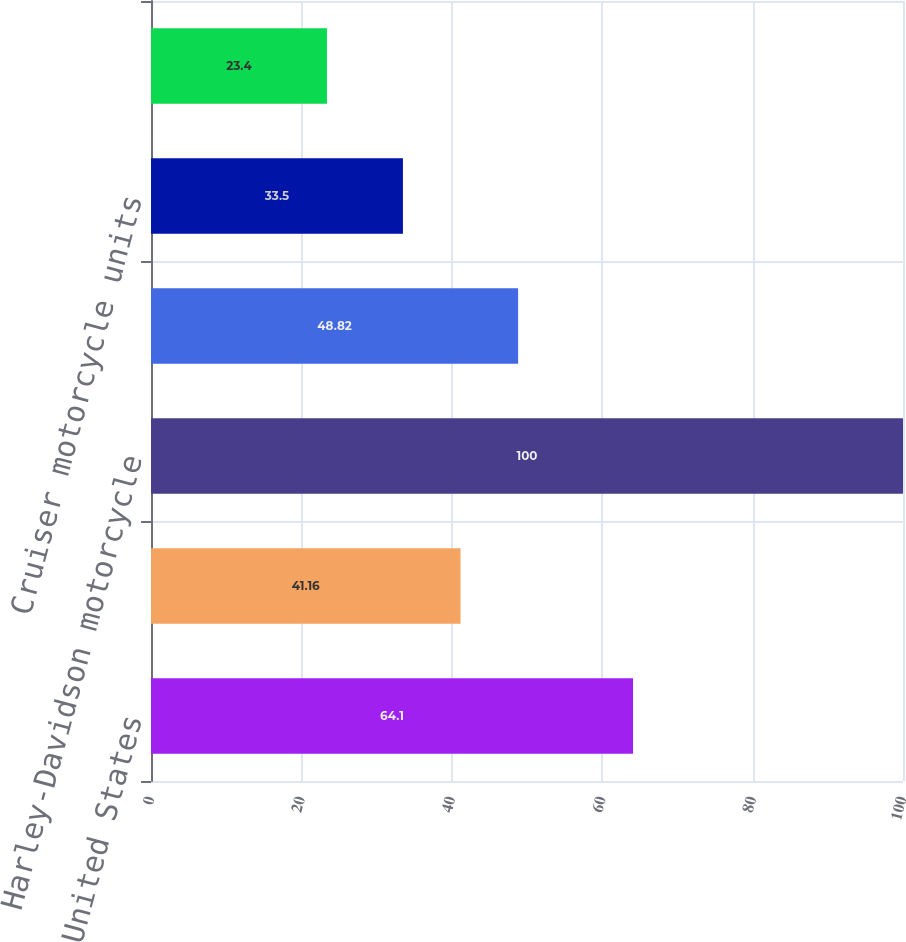Convert chart to OTSL. <chart><loc_0><loc_0><loc_500><loc_500><bar_chart><fcel>United States<fcel>International<fcel>Harley-Davidson motorcycle<fcel>Touring motorcycle units<fcel>Cruiser motorcycle units<fcel>Sportster^® / Street<nl><fcel>64.1<fcel>41.16<fcel>100<fcel>48.82<fcel>33.5<fcel>23.4<nl></chart> 